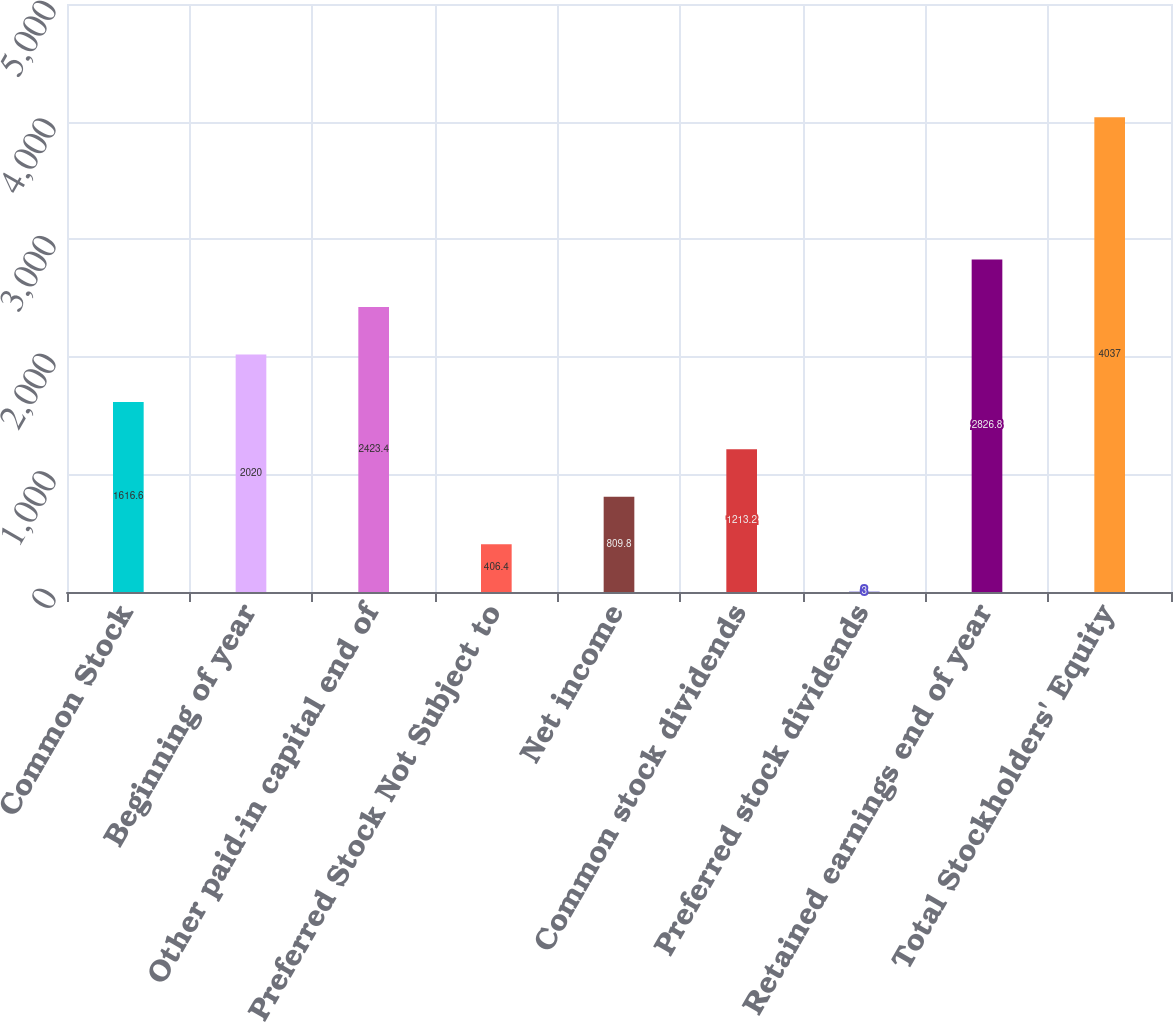Convert chart. <chart><loc_0><loc_0><loc_500><loc_500><bar_chart><fcel>Common Stock<fcel>Beginning of year<fcel>Other paid-in capital end of<fcel>Preferred Stock Not Subject to<fcel>Net income<fcel>Common stock dividends<fcel>Preferred stock dividends<fcel>Retained earnings end of year<fcel>Total Stockholders' Equity<nl><fcel>1616.6<fcel>2020<fcel>2423.4<fcel>406.4<fcel>809.8<fcel>1213.2<fcel>3<fcel>2826.8<fcel>4037<nl></chart> 